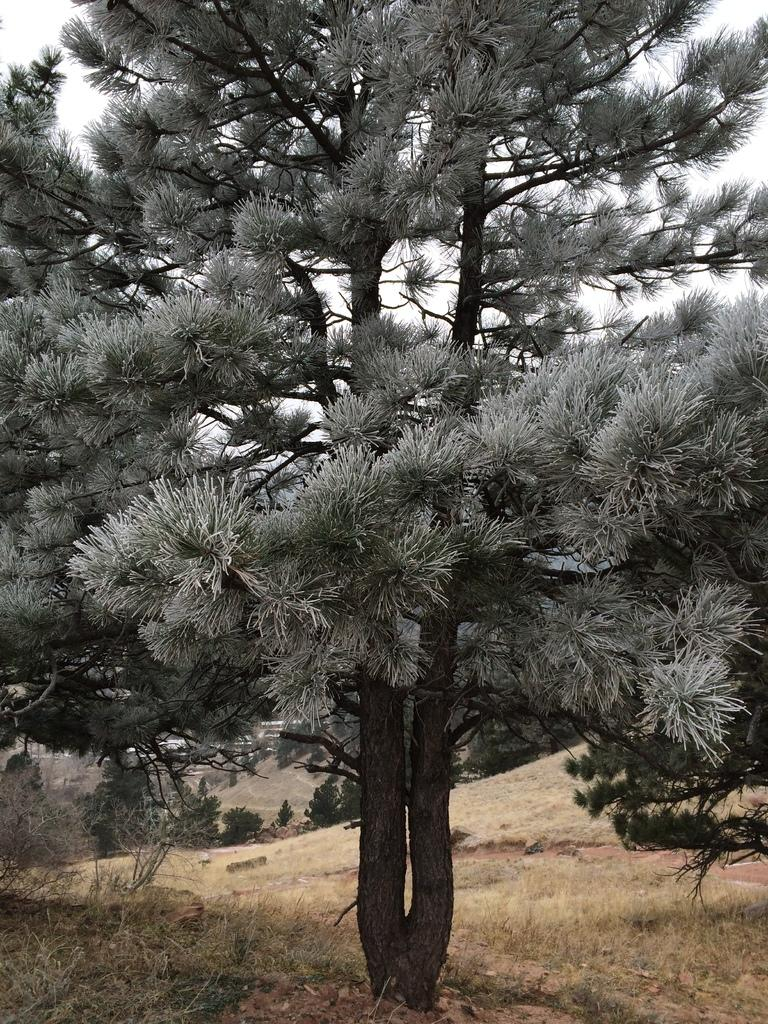What type of vegetation can be seen in the image? There are trees in the image. What else can be seen on the ground in the image? There is grass in the image. What is visible in the background of the image? The sky is visible in the background of the image. What type of page can be seen in the image? There is no page present in the image; it features trees, grass, and the sky. What type of stew is being prepared in the image? There is no stew or cooking activity present in the image. 